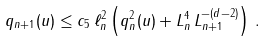<formula> <loc_0><loc_0><loc_500><loc_500>q _ { n + 1 } ( u ) \leq c _ { 5 } \, \ell ^ { 2 } _ { n } \left ( q ^ { 2 } _ { n } ( u ) + L ^ { 4 } _ { n } \, L ^ { - ( d - 2 ) } _ { n + 1 } \right ) \, .</formula> 